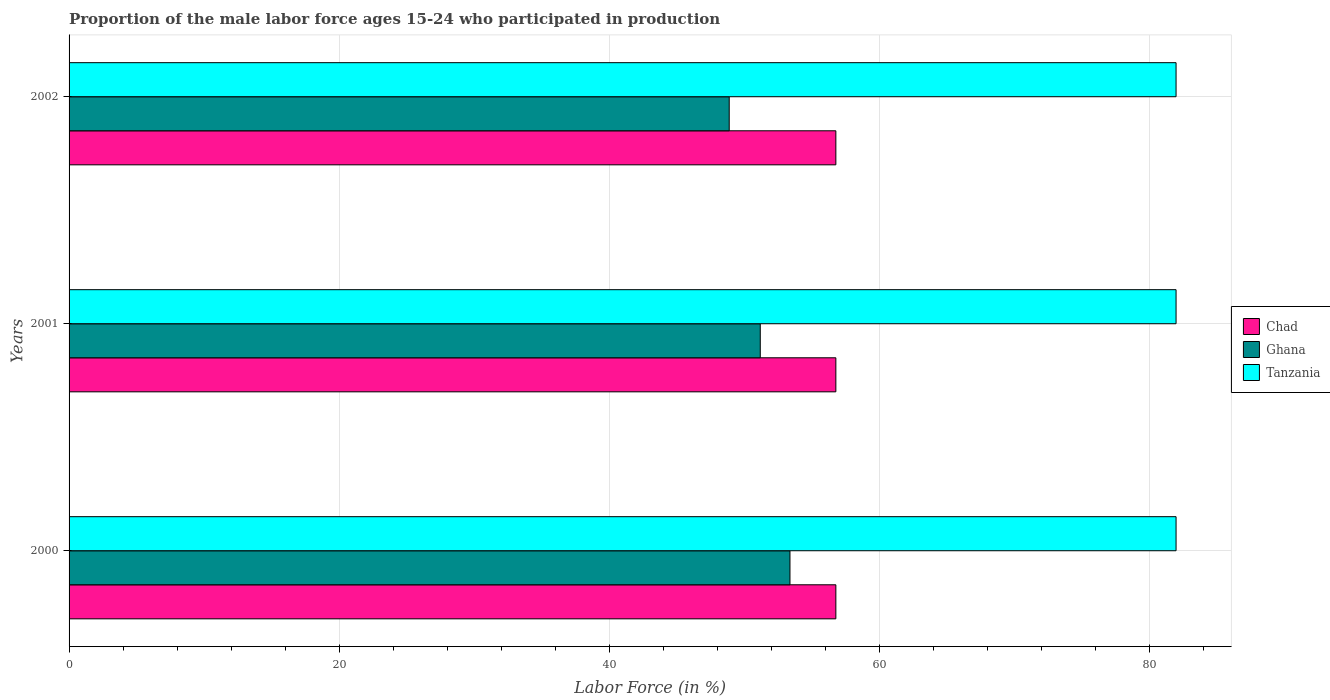How many different coloured bars are there?
Offer a very short reply. 3. Are the number of bars per tick equal to the number of legend labels?
Your answer should be very brief. Yes. Are the number of bars on each tick of the Y-axis equal?
Provide a short and direct response. Yes. How many bars are there on the 2nd tick from the bottom?
Your response must be concise. 3. What is the label of the 3rd group of bars from the top?
Give a very brief answer. 2000. What is the proportion of the male labor force who participated in production in Chad in 2001?
Your response must be concise. 56.8. Across all years, what is the maximum proportion of the male labor force who participated in production in Ghana?
Ensure brevity in your answer.  53.4. Across all years, what is the minimum proportion of the male labor force who participated in production in Chad?
Offer a terse response. 56.8. In which year was the proportion of the male labor force who participated in production in Ghana minimum?
Your answer should be very brief. 2002. What is the total proportion of the male labor force who participated in production in Ghana in the graph?
Offer a terse response. 153.5. What is the difference between the proportion of the male labor force who participated in production in Chad in 2000 and the proportion of the male labor force who participated in production in Ghana in 2001?
Keep it short and to the point. 5.6. What is the average proportion of the male labor force who participated in production in Ghana per year?
Your response must be concise. 51.17. In the year 2001, what is the difference between the proportion of the male labor force who participated in production in Chad and proportion of the male labor force who participated in production in Ghana?
Ensure brevity in your answer.  5.6. Is the proportion of the male labor force who participated in production in Tanzania in 2000 less than that in 2001?
Provide a succinct answer. No. What is the difference between the highest and the second highest proportion of the male labor force who participated in production in Tanzania?
Provide a short and direct response. 0. What is the difference between the highest and the lowest proportion of the male labor force who participated in production in Chad?
Your answer should be very brief. 0. What does the 3rd bar from the top in 2001 represents?
Keep it short and to the point. Chad. What does the 1st bar from the bottom in 2001 represents?
Offer a very short reply. Chad. How many bars are there?
Give a very brief answer. 9. Are all the bars in the graph horizontal?
Provide a short and direct response. Yes. How many years are there in the graph?
Offer a very short reply. 3. Are the values on the major ticks of X-axis written in scientific E-notation?
Your answer should be compact. No. Does the graph contain grids?
Your answer should be compact. Yes. Where does the legend appear in the graph?
Your response must be concise. Center right. What is the title of the graph?
Give a very brief answer. Proportion of the male labor force ages 15-24 who participated in production. What is the Labor Force (in %) of Chad in 2000?
Give a very brief answer. 56.8. What is the Labor Force (in %) in Ghana in 2000?
Ensure brevity in your answer.  53.4. What is the Labor Force (in %) in Chad in 2001?
Ensure brevity in your answer.  56.8. What is the Labor Force (in %) in Ghana in 2001?
Your response must be concise. 51.2. What is the Labor Force (in %) in Chad in 2002?
Provide a short and direct response. 56.8. What is the Labor Force (in %) of Ghana in 2002?
Your response must be concise. 48.9. Across all years, what is the maximum Labor Force (in %) in Chad?
Your response must be concise. 56.8. Across all years, what is the maximum Labor Force (in %) of Ghana?
Provide a succinct answer. 53.4. Across all years, what is the maximum Labor Force (in %) of Tanzania?
Your answer should be compact. 82. Across all years, what is the minimum Labor Force (in %) of Chad?
Provide a succinct answer. 56.8. Across all years, what is the minimum Labor Force (in %) in Ghana?
Your response must be concise. 48.9. What is the total Labor Force (in %) of Chad in the graph?
Offer a very short reply. 170.4. What is the total Labor Force (in %) in Ghana in the graph?
Make the answer very short. 153.5. What is the total Labor Force (in %) of Tanzania in the graph?
Your response must be concise. 246. What is the difference between the Labor Force (in %) of Chad in 2000 and that in 2001?
Make the answer very short. 0. What is the difference between the Labor Force (in %) of Ghana in 2000 and that in 2001?
Offer a terse response. 2.2. What is the difference between the Labor Force (in %) of Tanzania in 2000 and that in 2001?
Provide a succinct answer. 0. What is the difference between the Labor Force (in %) in Chad in 2000 and that in 2002?
Your answer should be compact. 0. What is the difference between the Labor Force (in %) in Tanzania in 2000 and that in 2002?
Keep it short and to the point. 0. What is the difference between the Labor Force (in %) in Chad in 2000 and the Labor Force (in %) in Tanzania in 2001?
Give a very brief answer. -25.2. What is the difference between the Labor Force (in %) in Ghana in 2000 and the Labor Force (in %) in Tanzania in 2001?
Keep it short and to the point. -28.6. What is the difference between the Labor Force (in %) in Chad in 2000 and the Labor Force (in %) in Ghana in 2002?
Provide a short and direct response. 7.9. What is the difference between the Labor Force (in %) in Chad in 2000 and the Labor Force (in %) in Tanzania in 2002?
Keep it short and to the point. -25.2. What is the difference between the Labor Force (in %) of Ghana in 2000 and the Labor Force (in %) of Tanzania in 2002?
Offer a terse response. -28.6. What is the difference between the Labor Force (in %) of Chad in 2001 and the Labor Force (in %) of Tanzania in 2002?
Give a very brief answer. -25.2. What is the difference between the Labor Force (in %) of Ghana in 2001 and the Labor Force (in %) of Tanzania in 2002?
Ensure brevity in your answer.  -30.8. What is the average Labor Force (in %) in Chad per year?
Your answer should be compact. 56.8. What is the average Labor Force (in %) in Ghana per year?
Give a very brief answer. 51.17. What is the average Labor Force (in %) of Tanzania per year?
Provide a succinct answer. 82. In the year 2000, what is the difference between the Labor Force (in %) in Chad and Labor Force (in %) in Tanzania?
Ensure brevity in your answer.  -25.2. In the year 2000, what is the difference between the Labor Force (in %) in Ghana and Labor Force (in %) in Tanzania?
Make the answer very short. -28.6. In the year 2001, what is the difference between the Labor Force (in %) of Chad and Labor Force (in %) of Ghana?
Keep it short and to the point. 5.6. In the year 2001, what is the difference between the Labor Force (in %) of Chad and Labor Force (in %) of Tanzania?
Give a very brief answer. -25.2. In the year 2001, what is the difference between the Labor Force (in %) in Ghana and Labor Force (in %) in Tanzania?
Provide a short and direct response. -30.8. In the year 2002, what is the difference between the Labor Force (in %) in Chad and Labor Force (in %) in Ghana?
Provide a succinct answer. 7.9. In the year 2002, what is the difference between the Labor Force (in %) in Chad and Labor Force (in %) in Tanzania?
Ensure brevity in your answer.  -25.2. In the year 2002, what is the difference between the Labor Force (in %) in Ghana and Labor Force (in %) in Tanzania?
Give a very brief answer. -33.1. What is the ratio of the Labor Force (in %) in Chad in 2000 to that in 2001?
Your response must be concise. 1. What is the ratio of the Labor Force (in %) in Ghana in 2000 to that in 2001?
Provide a succinct answer. 1.04. What is the ratio of the Labor Force (in %) in Tanzania in 2000 to that in 2001?
Give a very brief answer. 1. What is the ratio of the Labor Force (in %) in Ghana in 2000 to that in 2002?
Keep it short and to the point. 1.09. What is the ratio of the Labor Force (in %) in Tanzania in 2000 to that in 2002?
Give a very brief answer. 1. What is the ratio of the Labor Force (in %) of Chad in 2001 to that in 2002?
Keep it short and to the point. 1. What is the ratio of the Labor Force (in %) in Ghana in 2001 to that in 2002?
Offer a very short reply. 1.05. What is the ratio of the Labor Force (in %) in Tanzania in 2001 to that in 2002?
Provide a short and direct response. 1. What is the difference between the highest and the second highest Labor Force (in %) of Ghana?
Your response must be concise. 2.2. What is the difference between the highest and the second highest Labor Force (in %) in Tanzania?
Your answer should be very brief. 0. What is the difference between the highest and the lowest Labor Force (in %) in Ghana?
Your answer should be compact. 4.5. What is the difference between the highest and the lowest Labor Force (in %) of Tanzania?
Provide a short and direct response. 0. 